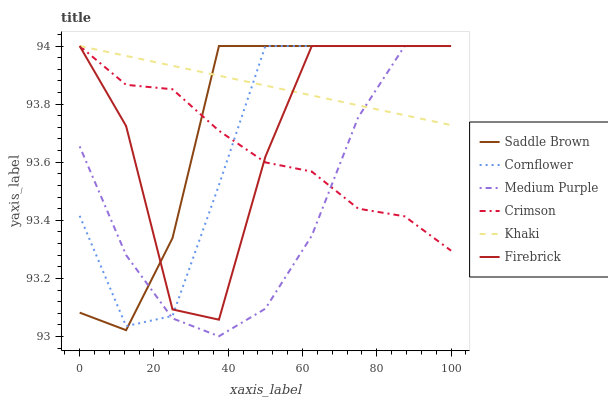Does Medium Purple have the minimum area under the curve?
Answer yes or no. Yes. Does Khaki have the maximum area under the curve?
Answer yes or no. Yes. Does Firebrick have the minimum area under the curve?
Answer yes or no. No. Does Firebrick have the maximum area under the curve?
Answer yes or no. No. Is Khaki the smoothest?
Answer yes or no. Yes. Is Firebrick the roughest?
Answer yes or no. Yes. Is Firebrick the smoothest?
Answer yes or no. No. Is Khaki the roughest?
Answer yes or no. No. Does Firebrick have the lowest value?
Answer yes or no. No. Does Saddle Brown have the highest value?
Answer yes or no. Yes. Does Saddle Brown intersect Cornflower?
Answer yes or no. Yes. Is Saddle Brown less than Cornflower?
Answer yes or no. No. Is Saddle Brown greater than Cornflower?
Answer yes or no. No. 